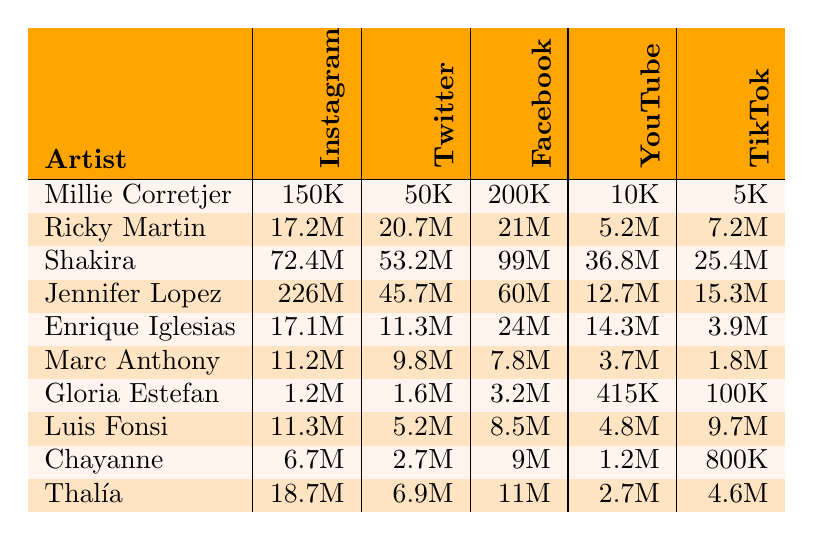What artist has the highest number of Instagram followers? By looking at the Instagram follower counts, Jennifer Lopez has 226 million followers, which is more than any other artist listed.
Answer: Jennifer Lopez Which artist has the least number of TikTok followers? Out of the TikTok followers, Gloria Estefan has only 100,000 followers, which is the lowest count.
Answer: Gloria Estefan What is the difference in Facebook likes between Shakira and Marc Anthony? Shakira has 99 million Facebook likes, and Marc Anthony has 7.8 million. The difference is 99 million - 7.8 million = 91.2 million.
Answer: 91.2 million Who has more Twitter followers, Enrique Iglesias or Chayanne? Enrique Iglesias has 11.3 million Twitter followers, whereas Chayanne has 2.7 million; thus, Enrique Iglesias has more followers.
Answer: Enrique Iglesias Calculate the average number of YouTube subscribers across all artists. The total YouTube subscribers can be calculated as 10K + 5.2M + 36.8M + 12.7M + 14.3M + 3.7M + 415K + 4.8M + 1.2M + 2.7M = 80.1 million. Dividing this by 10 artists gives an average of 8.01 million.
Answer: 8.01 million Is it true that Thalía has more Facebook likes than Luis Fonsi? Thalía has 11 million Facebook likes and Luis Fonsi has 8.5 million; therefore, Thalía does indeed have more likes.
Answer: Yes Which platform has the highest total follower count across all artists? Adding up followers from all platforms: Instagram (150K + 17.2M + 72.4M + 226M + 17.1M + 11.2M + 1.2M + 11.3M + 6.7M + 18.7M), Twitter (50K + 20.7M + 53.2M + 45.7M + 11.3M + 9.8M + 1.6M + 5.2M + 2.7M + 6.9M), Facebook (200K + 21M + 99M + 60M + 24M + 7.8M + 3.2M + 8.5M + 9M + 11M), YouTube (10K + 5.2M + 36.8M + 12.7M + 14.3M + 3.7M + 415K + 4.8M + 1.2M + 2.7M), TikTok (5K + 7.2M + 25.4M + 15.3M + 3.9M + 1.8M + 100K + 9.7M + 800K + 4.6M). After adding, Facebook has the highest total count.
Answer: Facebook Which artist has the highest total follower count when combining all social media platforms? To find the highest total, we sum each artist's followers across Instagram, Twitter, Facebook, YouTube, and TikTok, which shows that Jennifer Lopez has the highest total with 226M from Instagram, 45.7M from Twitter, 60M from Facebook, 12.7M from YouTube, and 15.3M from TikTok. This totals to 359.7 million followers.
Answer: Jennifer Lopez 